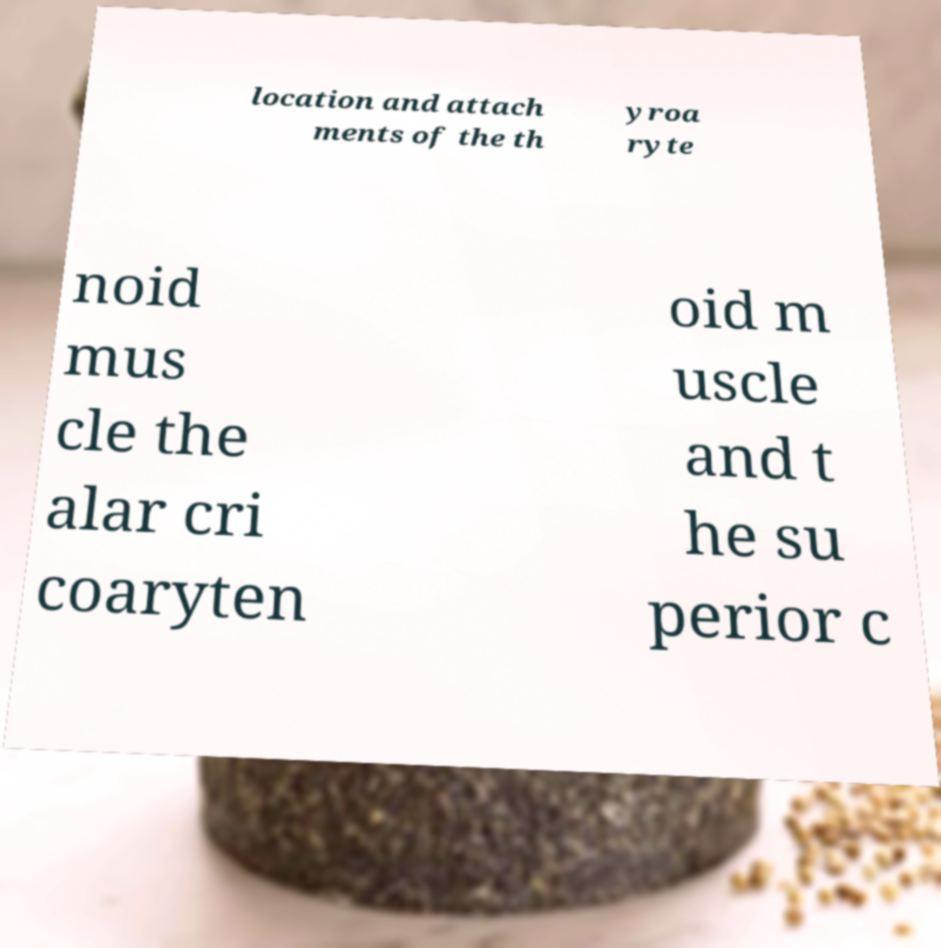Could you extract and type out the text from this image? location and attach ments of the th yroa ryte noid mus cle the alar cri coaryten oid m uscle and t he su perior c 